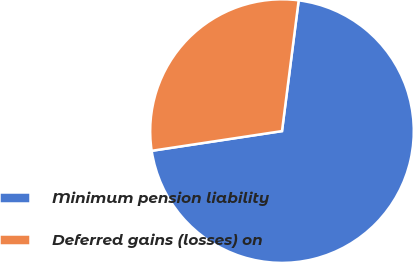<chart> <loc_0><loc_0><loc_500><loc_500><pie_chart><fcel>Minimum pension liability<fcel>Deferred gains (losses) on<nl><fcel>70.59%<fcel>29.41%<nl></chart> 